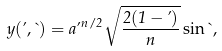Convert formula to latex. <formula><loc_0><loc_0><loc_500><loc_500>y ( \varphi , \theta ) = a \varphi ^ { n / 2 } \sqrt { \frac { 2 ( 1 - \varphi ) } { n } } \sin \theta ,</formula> 